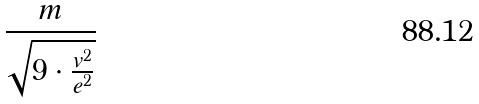<formula> <loc_0><loc_0><loc_500><loc_500>\frac { m } { \sqrt { 9 \cdot \frac { v ^ { 2 } } { e ^ { 2 } } } }</formula> 